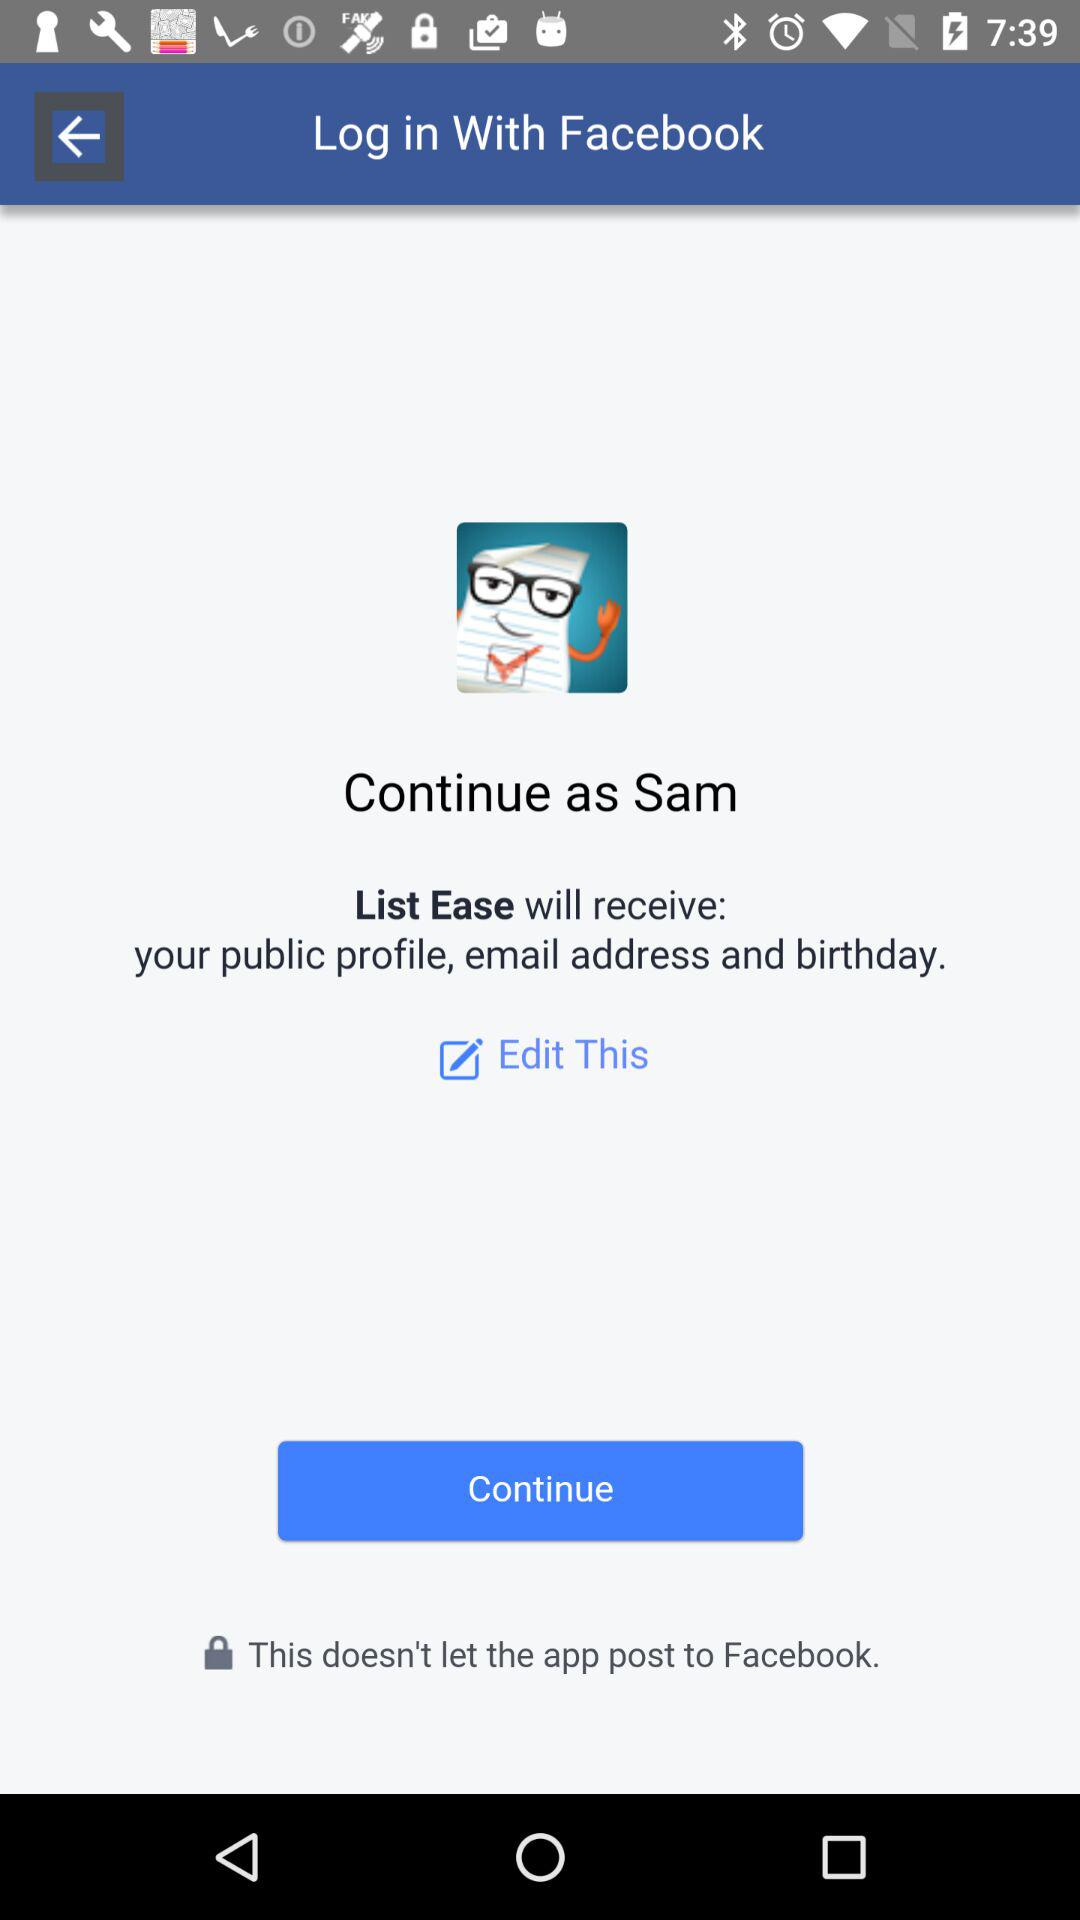What applications can be used to log in to the profile? The application that can be used to log in to the profile is "Facebook". 